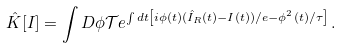Convert formula to latex. <formula><loc_0><loc_0><loc_500><loc_500>\hat { K } [ I ] = \int D \phi \mathcal { T } e ^ { \int d t \left [ i \phi ( t ) ( \hat { I } _ { R } ( t ) - I ( t ) ) / e - \phi ^ { 2 } ( t ) / \tau \right ] } \, .</formula> 